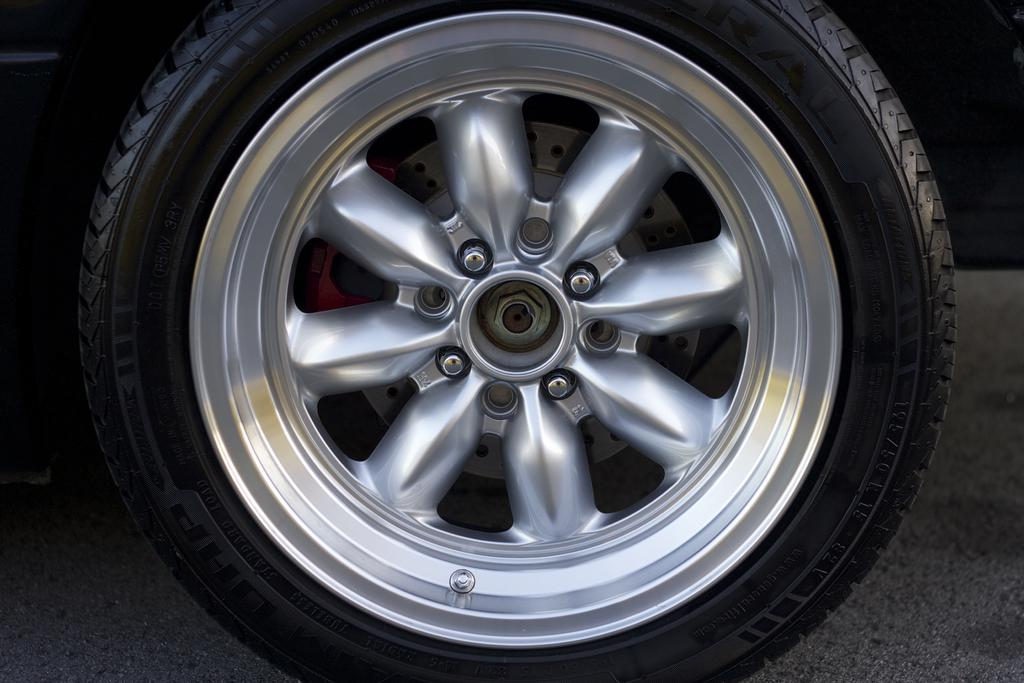What is the main subject of the image? The main subject of the image is a picture of a wheel tire. What type of pancake is being prepared on the wheel tire in the image? There is no pancake present in the image, and the wheel tire is not being used for cooking or preparing food. 